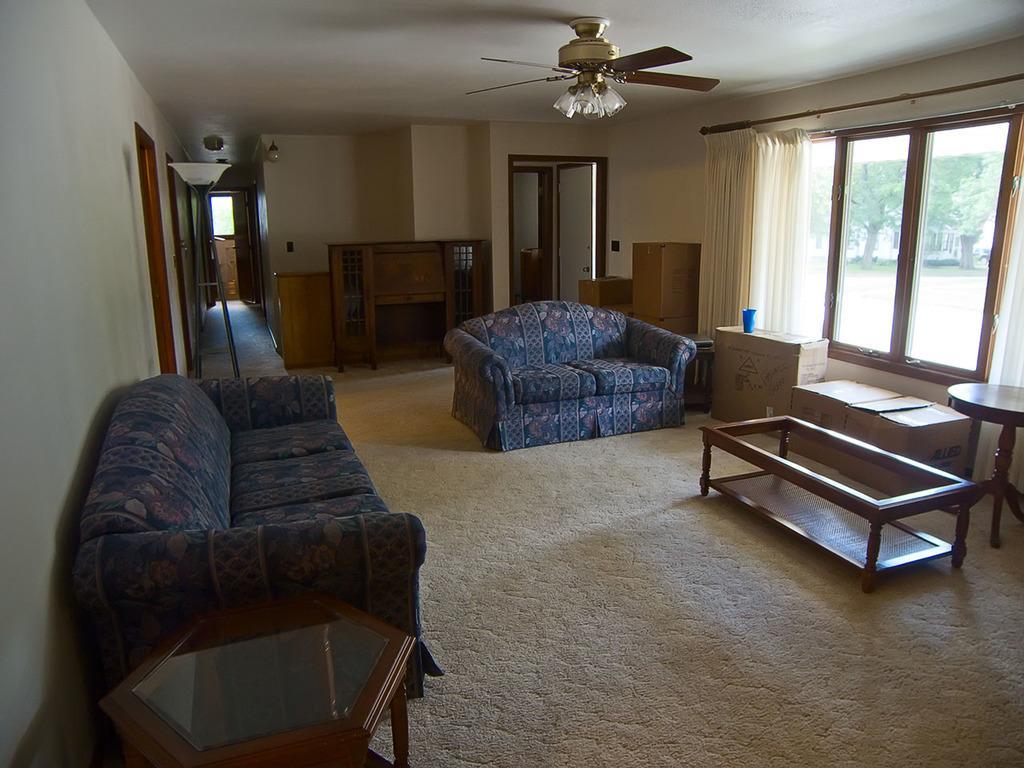Can you describe this image briefly? This picture is clicked the inside the room. Here we see sofa. Beside that, we see a table and on right corner of table, we see stool and beside that, we see cotton boxes and windows from which we see trees and buildings outside the room and we even see white curtain. On top of the picture, we see fan and behind the sofa, we see wall which is white in color and white door and on the bottom of the picture, we see a white carpet placed on the floor. 